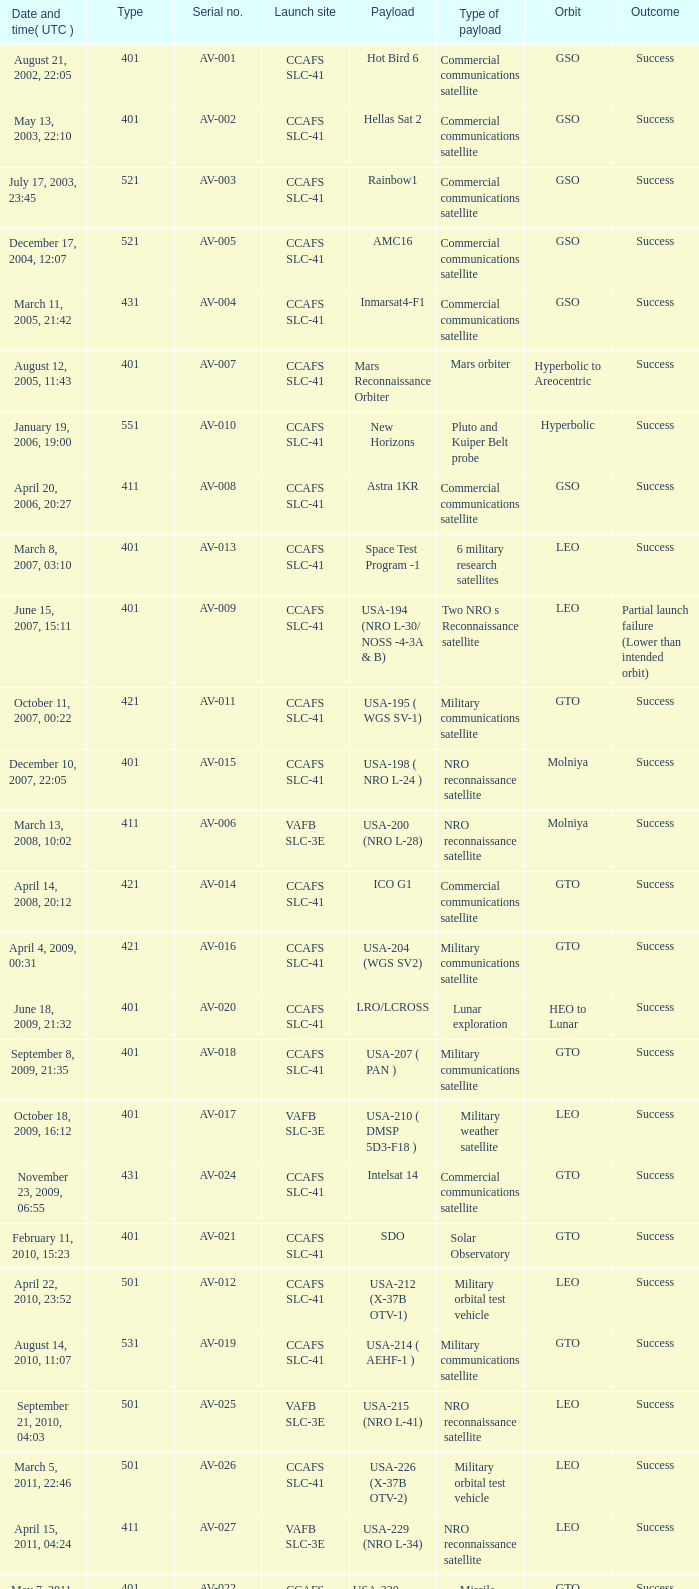For the payload of Van Allen Belts Exploration what's the serial number? AV-032. Can you parse all the data within this table? {'header': ['Date and time( UTC )', 'Type', 'Serial no.', 'Launch site', 'Payload', 'Type of payload', 'Orbit', 'Outcome'], 'rows': [['August 21, 2002, 22:05', '401', 'AV-001', 'CCAFS SLC-41', 'Hot Bird 6', 'Commercial communications satellite', 'GSO', 'Success'], ['May 13, 2003, 22:10', '401', 'AV-002', 'CCAFS SLC-41', 'Hellas Sat 2', 'Commercial communications satellite', 'GSO', 'Success'], ['July 17, 2003, 23:45', '521', 'AV-003', 'CCAFS SLC-41', 'Rainbow1', 'Commercial communications satellite', 'GSO', 'Success'], ['December 17, 2004, 12:07', '521', 'AV-005', 'CCAFS SLC-41', 'AMC16', 'Commercial communications satellite', 'GSO', 'Success'], ['March 11, 2005, 21:42', '431', 'AV-004', 'CCAFS SLC-41', 'Inmarsat4-F1', 'Commercial communications satellite', 'GSO', 'Success'], ['August 12, 2005, 11:43', '401', 'AV-007', 'CCAFS SLC-41', 'Mars Reconnaissance Orbiter', 'Mars orbiter', 'Hyperbolic to Areocentric', 'Success'], ['January 19, 2006, 19:00', '551', 'AV-010', 'CCAFS SLC-41', 'New Horizons', 'Pluto and Kuiper Belt probe', 'Hyperbolic', 'Success'], ['April 20, 2006, 20:27', '411', 'AV-008', 'CCAFS SLC-41', 'Astra 1KR', 'Commercial communications satellite', 'GSO', 'Success'], ['March 8, 2007, 03:10', '401', 'AV-013', 'CCAFS SLC-41', 'Space Test Program -1', '6 military research satellites', 'LEO', 'Success'], ['June 15, 2007, 15:11', '401', 'AV-009', 'CCAFS SLC-41', 'USA-194 (NRO L-30/ NOSS -4-3A & B)', 'Two NRO s Reconnaissance satellite', 'LEO', 'Partial launch failure (Lower than intended orbit)'], ['October 11, 2007, 00:22', '421', 'AV-011', 'CCAFS SLC-41', 'USA-195 ( WGS SV-1)', 'Military communications satellite', 'GTO', 'Success'], ['December 10, 2007, 22:05', '401', 'AV-015', 'CCAFS SLC-41', 'USA-198 ( NRO L-24 )', 'NRO reconnaissance satellite', 'Molniya', 'Success'], ['March 13, 2008, 10:02', '411', 'AV-006', 'VAFB SLC-3E', 'USA-200 (NRO L-28)', 'NRO reconnaissance satellite', 'Molniya', 'Success'], ['April 14, 2008, 20:12', '421', 'AV-014', 'CCAFS SLC-41', 'ICO G1', 'Commercial communications satellite', 'GTO', 'Success'], ['April 4, 2009, 00:31', '421', 'AV-016', 'CCAFS SLC-41', 'USA-204 (WGS SV2)', 'Military communications satellite', 'GTO', 'Success'], ['June 18, 2009, 21:32', '401', 'AV-020', 'CCAFS SLC-41', 'LRO/LCROSS', 'Lunar exploration', 'HEO to Lunar', 'Success'], ['September 8, 2009, 21:35', '401', 'AV-018', 'CCAFS SLC-41', 'USA-207 ( PAN )', 'Military communications satellite', 'GTO', 'Success'], ['October 18, 2009, 16:12', '401', 'AV-017', 'VAFB SLC-3E', 'USA-210 ( DMSP 5D3-F18 )', 'Military weather satellite', 'LEO', 'Success'], ['November 23, 2009, 06:55', '431', 'AV-024', 'CCAFS SLC-41', 'Intelsat 14', 'Commercial communications satellite', 'GTO', 'Success'], ['February 11, 2010, 15:23', '401', 'AV-021', 'CCAFS SLC-41', 'SDO', 'Solar Observatory', 'GTO', 'Success'], ['April 22, 2010, 23:52', '501', 'AV-012', 'CCAFS SLC-41', 'USA-212 (X-37B OTV-1)', 'Military orbital test vehicle', 'LEO', 'Success'], ['August 14, 2010, 11:07', '531', 'AV-019', 'CCAFS SLC-41', 'USA-214 ( AEHF-1 )', 'Military communications satellite', 'GTO', 'Success'], ['September 21, 2010, 04:03', '501', 'AV-025', 'VAFB SLC-3E', 'USA-215 (NRO L-41)', 'NRO reconnaissance satellite', 'LEO', 'Success'], ['March 5, 2011, 22:46', '501', 'AV-026', 'CCAFS SLC-41', 'USA-226 (X-37B OTV-2)', 'Military orbital test vehicle', 'LEO', 'Success'], ['April 15, 2011, 04:24', '411', 'AV-027', 'VAFB SLC-3E', 'USA-229 (NRO L-34)', 'NRO reconnaissance satellite', 'LEO', 'Success'], ['May 7, 2011, 18:10', '401', 'AV-022', 'CCAFS SLC-41', 'USA-230 (SBIRS-GEO-1)', 'Missile Warning satellite', 'GTO', 'Success'], ['August 5, 2011, 16:25', '551', 'AV-029', 'CCAFS SLC-41', 'Juno', 'Jupiter orbiter', 'Hyperbolic to Jovicentric', 'Success'], ['November 26, 2011, 15:02', '541', 'AV-028', 'CCAFS SLC-41', 'Mars Science Laboratory', 'Mars rover', 'Hyperbolic (Mars landing)', 'Success'], ['February 24, 2012, 22:15', '551', 'AV-030', 'CCAFS SLC-41', 'MUOS-1', 'Military communications satellite', 'GTO', 'Success'], ['May 4, 2012, 18:42', '531', 'AV-031', 'CCAFS SLC-41', 'USA-235 ( AEHF-2 )', 'Military communications satellite', 'GTO', 'Success'], ['June 20, 2012, 12:28', '401', 'AV-023', 'CCAFS SLC-41', 'USA-236 (NROL-38)', 'NRO reconnaissance satellite', 'GEO', 'Success'], ['August 30, 2012, 08:05', '401', 'AV-032', 'CCAFS SLC-41', 'Van Allen Probes (RBSP)', 'Van Allen Belts exploration', 'MEO', 'Success'], ['September 13, 2012, 21:39', '401', 'AV-033', 'VAFB SLC-3E', 'USA-238 (NROL-36)', 'NRO reconnaissance satellites', 'LEO', 'Success'], ['December 11, 2012, 18:03', '501', 'AV-034', 'CCAFS SLC-41', 'USA-240 (X-37B OTV-3)', 'Military orbital test vehicle', 'LEO', 'Success'], ['January 31, 2013, 01:48', '401', 'AV-036', 'CCAFS SLC-41', 'TDRS-11 (TDRS-K)', 'Data relay satellite', 'GTO', 'Success'], ['February 11, 2013, 18:02', '401', 'AV-035', 'VAFB SLC-3E', 'Landsat 8', 'Earth Observation satellite', 'LEO', 'Success'], ['March 19, 2013, 21:21', '401', 'AV-037', 'CCAFS SLC-41', 'USA-241 ( SBIRS-GEO 2 )', 'Missile Warning satellite', 'GTO', 'Success'], ['May 15, 2013, 21:38', '401', 'AV-039', 'CCAFS SLC-41', 'USA-242 ( GPS IIF-4 )', 'Navigation satellite', 'MEO', 'Success'], ['July 19, 2013, 13:00', '551', 'AV-040', 'CCAFS SLC-41', 'MUOS-2', 'Military Communications satellite', 'GTO', 'Success'], ['September 18, 2013, 08:10', '531', 'AV-041', 'CCAFS SLC-41', 'USA-246 (AEHF-3)', 'Military communications satellite', 'GTO', 'Success']]} 